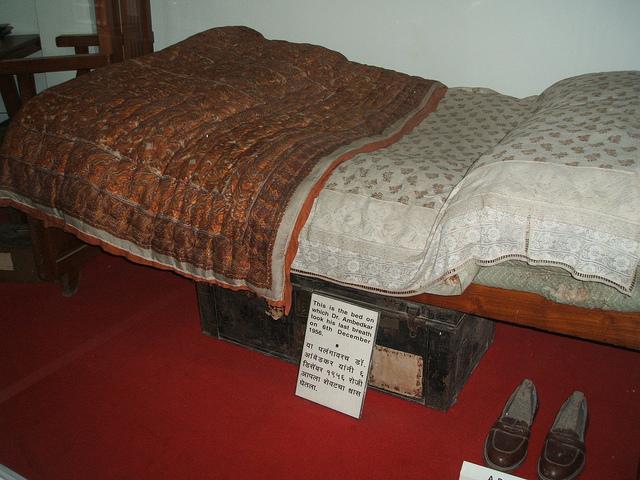Is this bed made?
Be succinct. Yes. What happened on this bed?
Answer briefly. Nothing. Will someone sleep on the bed tonight?
Answer briefly. No. 